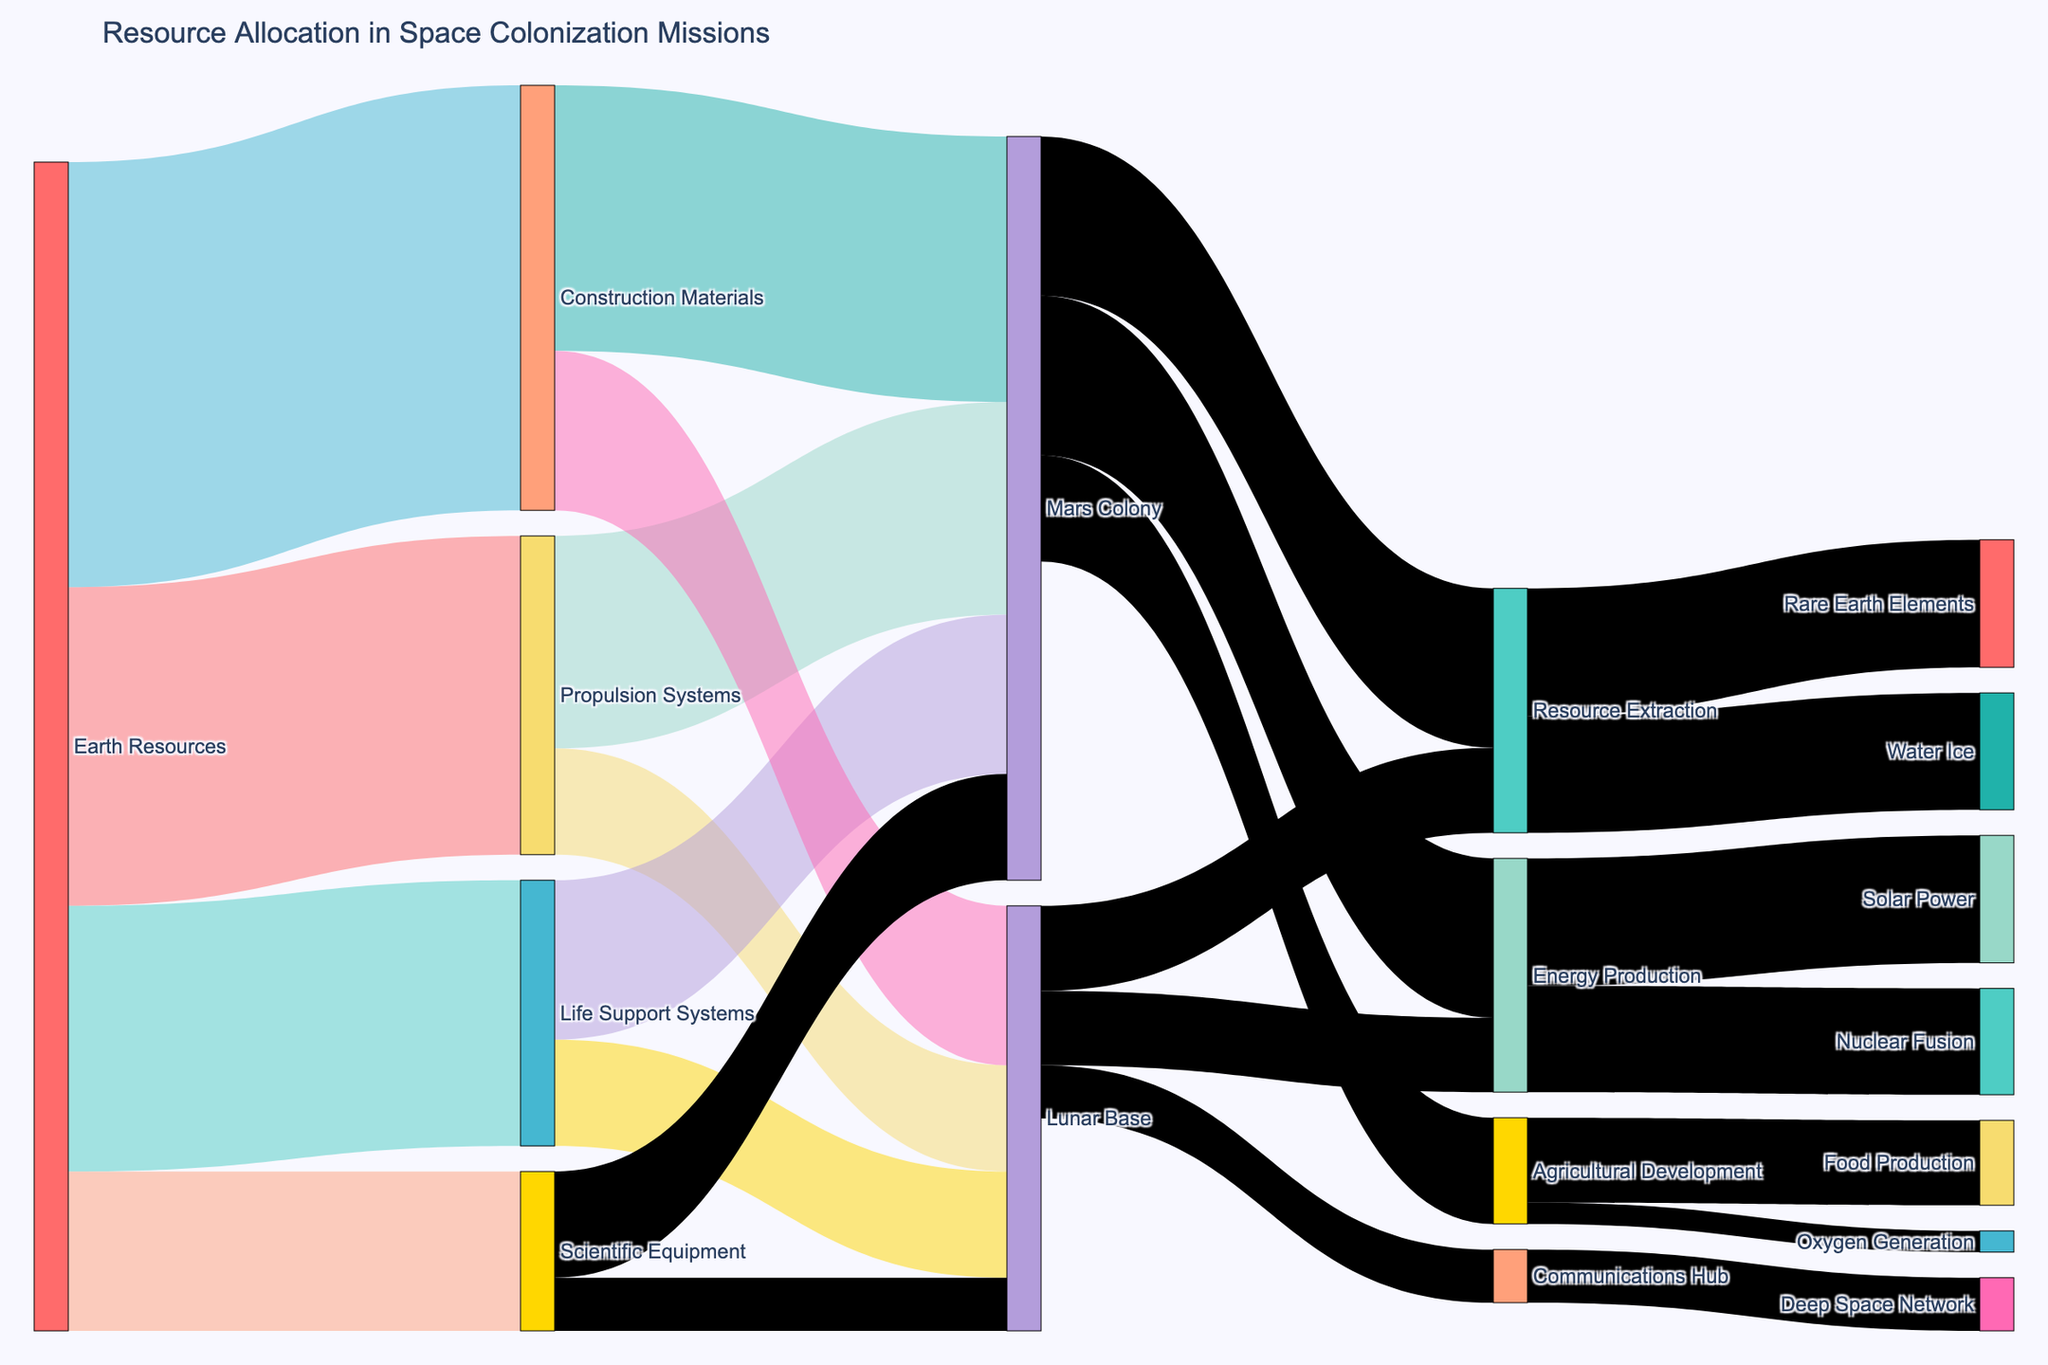what is the total amount of Earth resources allocated to the Mars Colony? Total Earth Resources allocated to the Mars Colony is the sum of resources from Propulsion Systems (2000) + Life Support Systems (1500) + Construction Materials (2500) + Scientific Equipment (1000). Thus, 2000 + 1500 + 2500 + 1000 = 7000.
Answer: 7000 What is the smaller quantity between the resources allocated to Lunar Base from Life Support Systems and Scientific Equipment? The resources allocated from Life Support Systems to Lunar Base is 1000 and from Scientific Equipment to Lunar Base is 500. Therefore, the smaller quantity is 500.
Answer: 500 How much Resource Extraction does Mars Colony contribute to compared to the Lunar Base? From the Sankey Diagram, Mars Colony contributes 1500 to Resource Extraction, whereas Lunar Base contributes 800. The difference is 1500 - 800 = 700.
Answer: 700 Which category receives the most resources from Earth? The data shows Earth allocates 4000 resources to Construction Materials, which is the highest compared to Propulsion Systems (3000), Life Support Systems (2500), and Scientific Equipment (1500).
Answer: Construction Materials What is the total amount of resources Earth allocates to Propulsion Systems, Life Support Systems, and Scientific Equipment combined? Total resources allocated to these systems is the sum of Propulsion Systems (3000) + Life Support Systems (2500) + Scientific Equipment (1500). Thus, 3000 + 2500 + 1500 = 7000.
Answer: 7000 Between Mars Colony and Lunar Base, which one receives more total resources from Earth? Mars Colony receives 2000 (Propulsion Systems) + 1500 (Life Support Systems) + 2500 (Construction Materials) + 1000 (Scientific Equipment) = 7000. Lunar Base receives 1000 (Propulsion Systems) + 1000 (Life Support Systems) + 1500 (Construction Materials) + 500 (Scientific Equipment) = 4000. As 7000 > 4000, Mars Colony receives more total resources.
Answer: Mars Colony What are the contributions to Energy Production from Mars Colony and Lunar Base combined? From the figure, Mars Colony contributes 1500 to Energy Production and Lunar Base contributes 700. Therefore, combined contribution is 1500 + 700 = 2200.
Answer: 2200 What is the difference between the amount of Scientific Equipment sent to the Mars Colony and the Lunar Base? Mars Colony receives 1000 while Lunar Base receives 500. The difference is 1000 - 500 = 500.
Answer: 500 What portion of Earth Resources are allocated to Construction Materials? The figure shows Earth allocates 4000 to Construction Materials out of a total of 3000 (Propulsion Systems) + 2500 (Life Support Systems) + 4000 (Construction Materials) + 1500 (Scientific Equipment) = 11000. This forms 4000/11000 = 36.36%.
Answer: 36.36% 